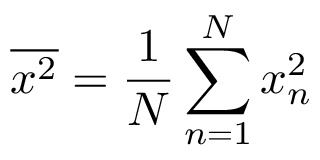Convert formula to latex. <formula><loc_0><loc_0><loc_500><loc_500>\overline { { x ^ { 2 } } } = \frac { 1 } { N } \sum _ { n = 1 } ^ { N } x _ { n } ^ { 2 }</formula> 